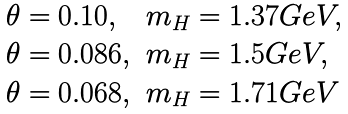Convert formula to latex. <formula><loc_0><loc_0><loc_500><loc_500>\begin{array} { l l } { \theta = 0 . 1 0 , } & { { m _ { H } = 1 . 3 7 G e V , } } \\ { \theta = 0 . 0 8 6 , } & { { m _ { H } = 1 . 5 G e V , } } \\ { \theta = 0 . 0 6 8 , } & { { m _ { H } = 1 . 7 1 G e V } } \end{array}</formula> 